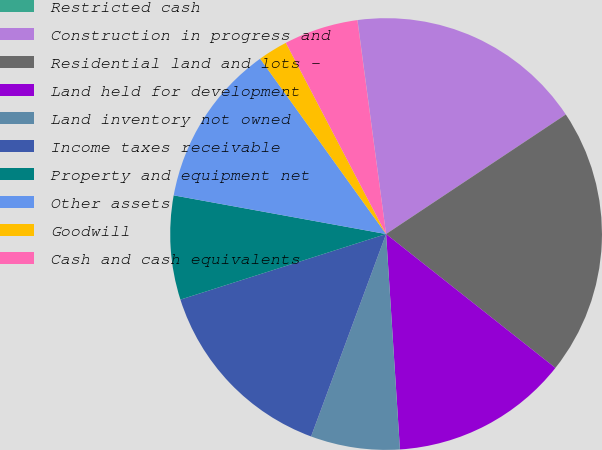Convert chart to OTSL. <chart><loc_0><loc_0><loc_500><loc_500><pie_chart><fcel>Restricted cash<fcel>Construction in progress and<fcel>Residential land and lots -<fcel>Land held for development<fcel>Land inventory not owned<fcel>Income taxes receivable<fcel>Property and equipment net<fcel>Other assets<fcel>Goodwill<fcel>Cash and cash equivalents<nl><fcel>0.01%<fcel>17.77%<fcel>19.99%<fcel>13.33%<fcel>6.67%<fcel>14.44%<fcel>7.78%<fcel>12.22%<fcel>2.23%<fcel>5.56%<nl></chart> 